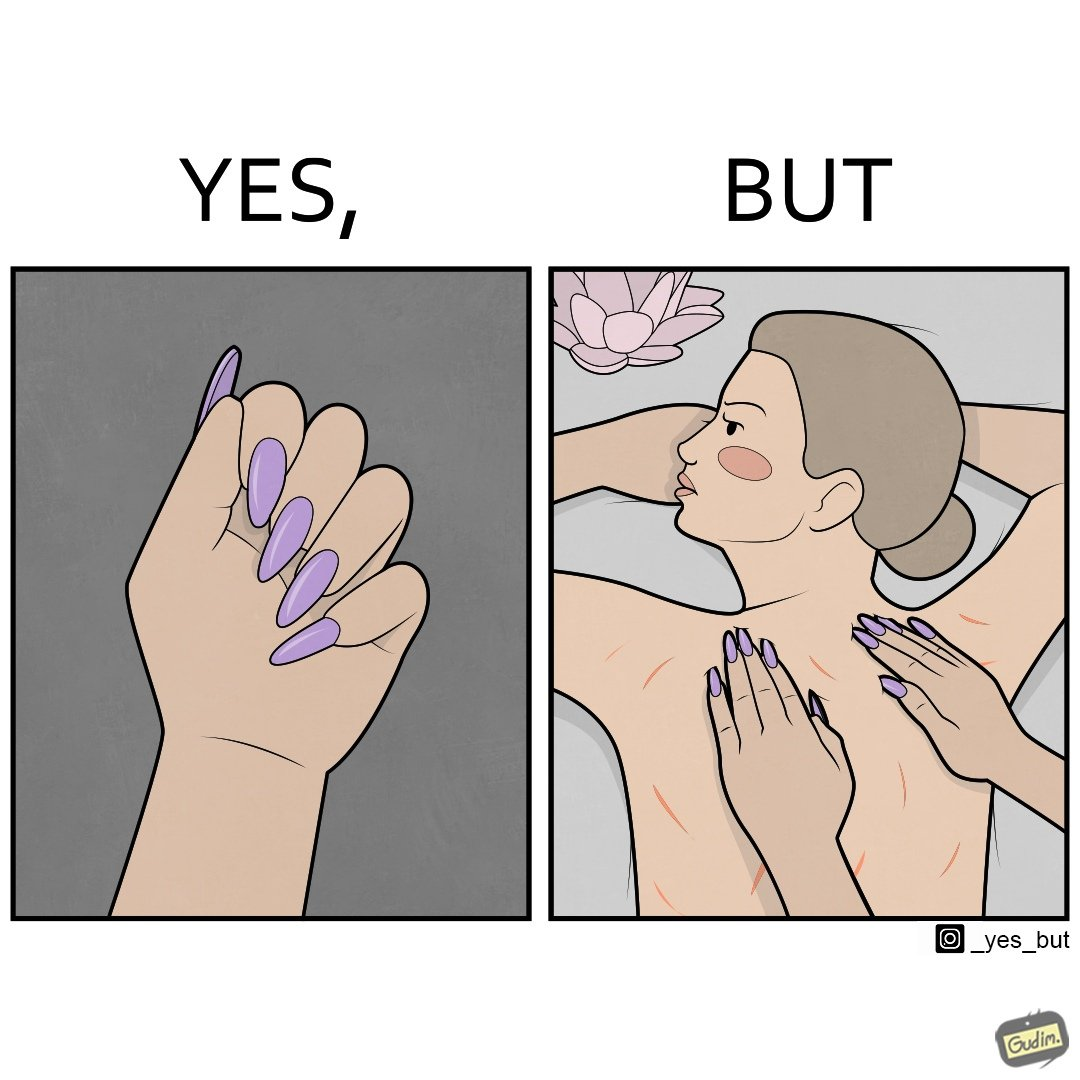What makes this image funny or satirical? The images are funny since it shows that even though the polished and colorful long nails look pretty and fashionable, the hinder the masseuse's ability to do her job of providing relaxing massages and hurts her customers 